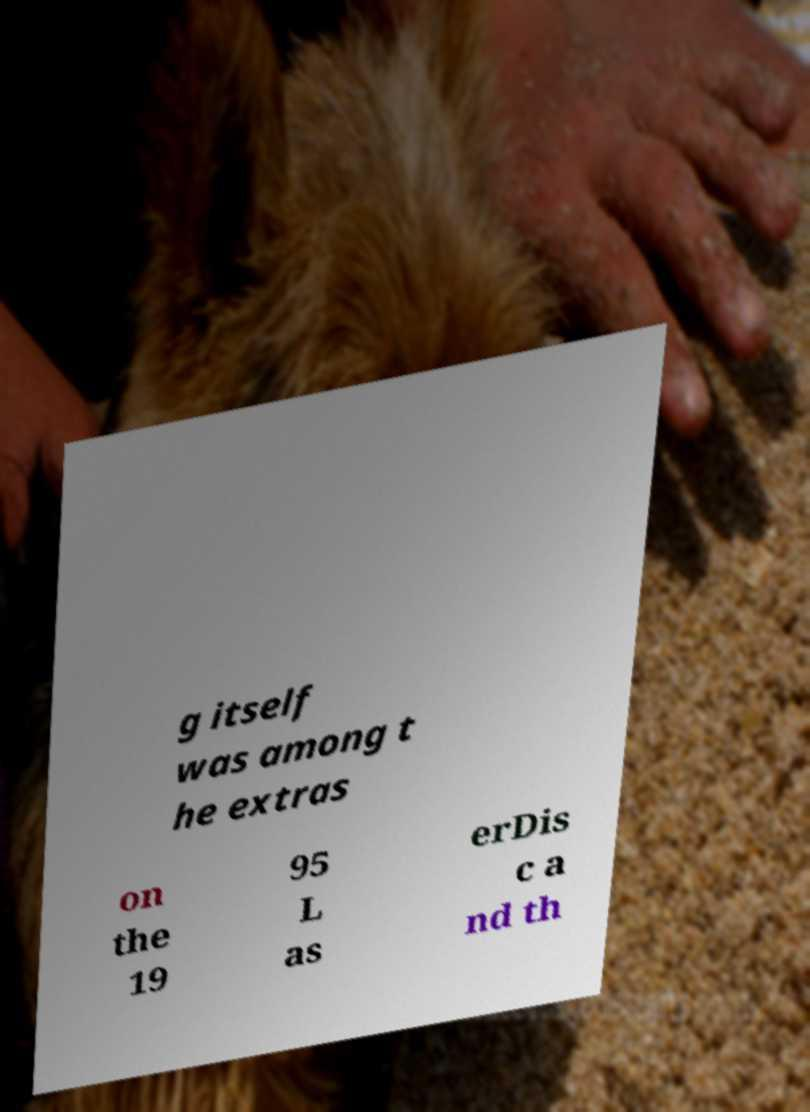Could you assist in decoding the text presented in this image and type it out clearly? g itself was among t he extras on the 19 95 L as erDis c a nd th 